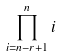Convert formula to latex. <formula><loc_0><loc_0><loc_500><loc_500>\prod _ { i = n - r + 1 } ^ { n } i</formula> 